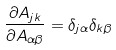<formula> <loc_0><loc_0><loc_500><loc_500>\frac { \partial A _ { j k } } { \partial A _ { \alpha \beta } } = \delta _ { j \alpha } \delta _ { k \beta }</formula> 